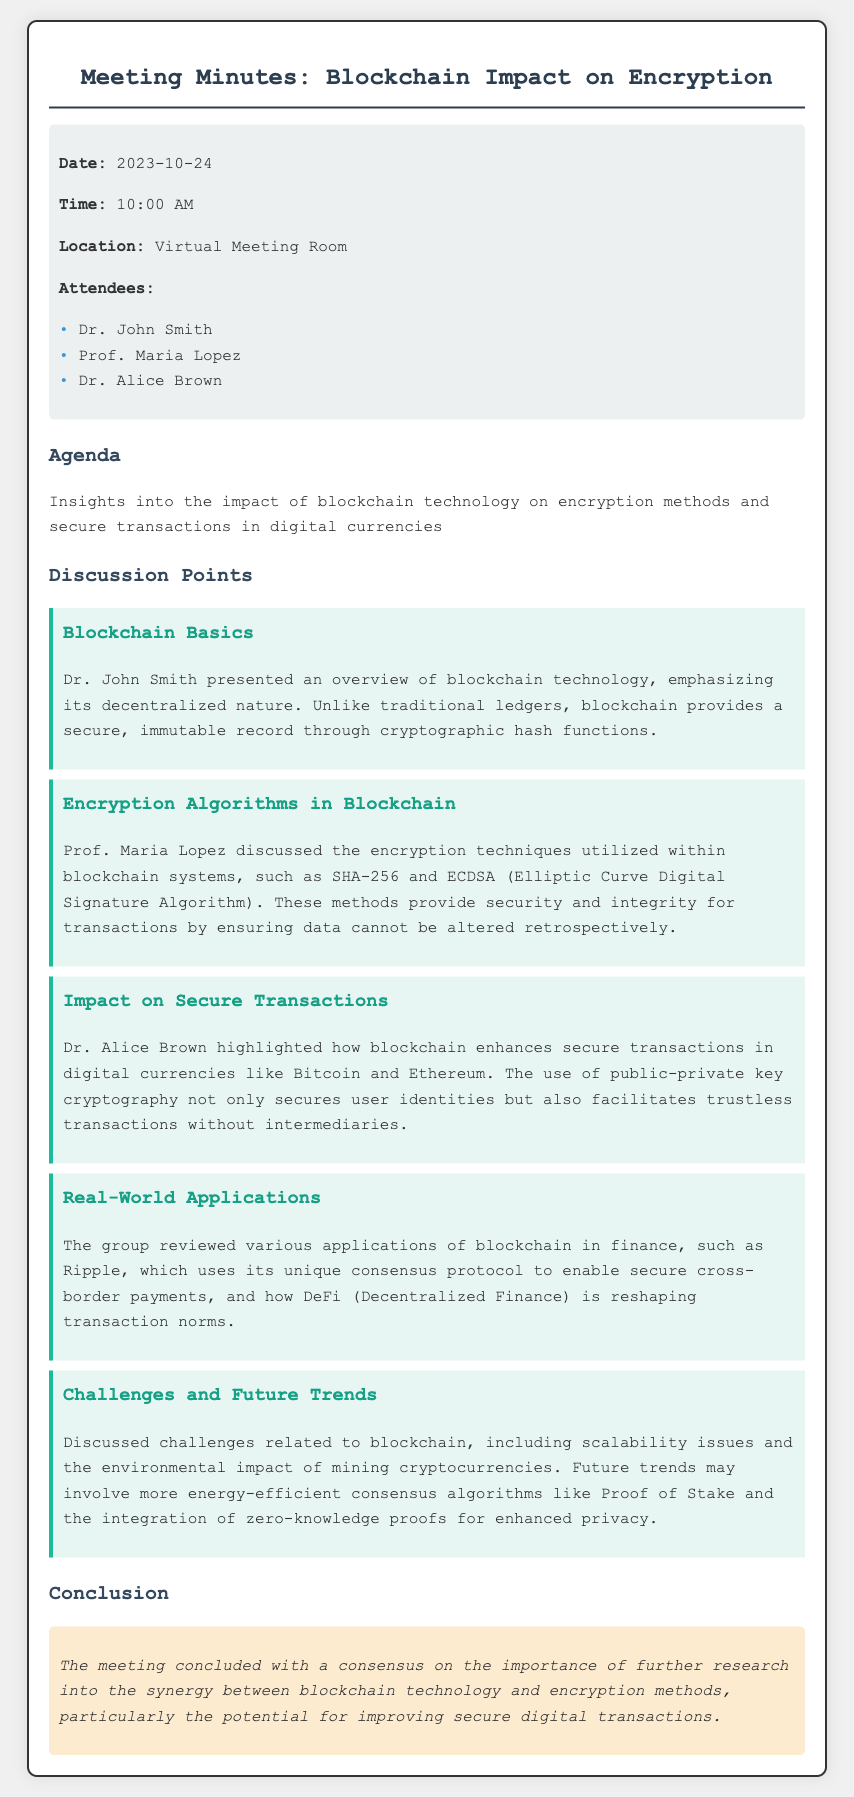what is the date of the meeting? The date of the meeting is specified in the meta information section of the document.
Answer: 2023-10-24 who presented the overview of blockchain technology? The presenter of the blockchain overview is mentioned in the discussion points section.
Answer: Dr. John Smith which encryption technique was discussed by Prof. Maria Lopez? The specific encryption technique mentioned is found in the topic about encryption algorithms.
Answer: SHA-256 what was highlighted by Dr. Alice Brown regarding transactions? Dr. Alice Brown's main point is stated in the discussion about secure transactions.
Answer: public-private key cryptography what application of blockchain was reviewed during the meeting? The applications of blockchain discussed include various examples mentioned in the real-world applications section.
Answer: Ripple what challenges related to blockchain were discussed? The challenges mentioned are found in the section covering challenges and future trends.
Answer: scalability issues what conclusion was reached at the end of the meeting? The conclusion of the meeting is summarized in the conclusion section.
Answer: importance of further research who attended the meeting? The list of attendees is provided in the meta information section.
Answer: Dr. John Smith, Prof. Maria Lopez, Dr. Alice Brown 